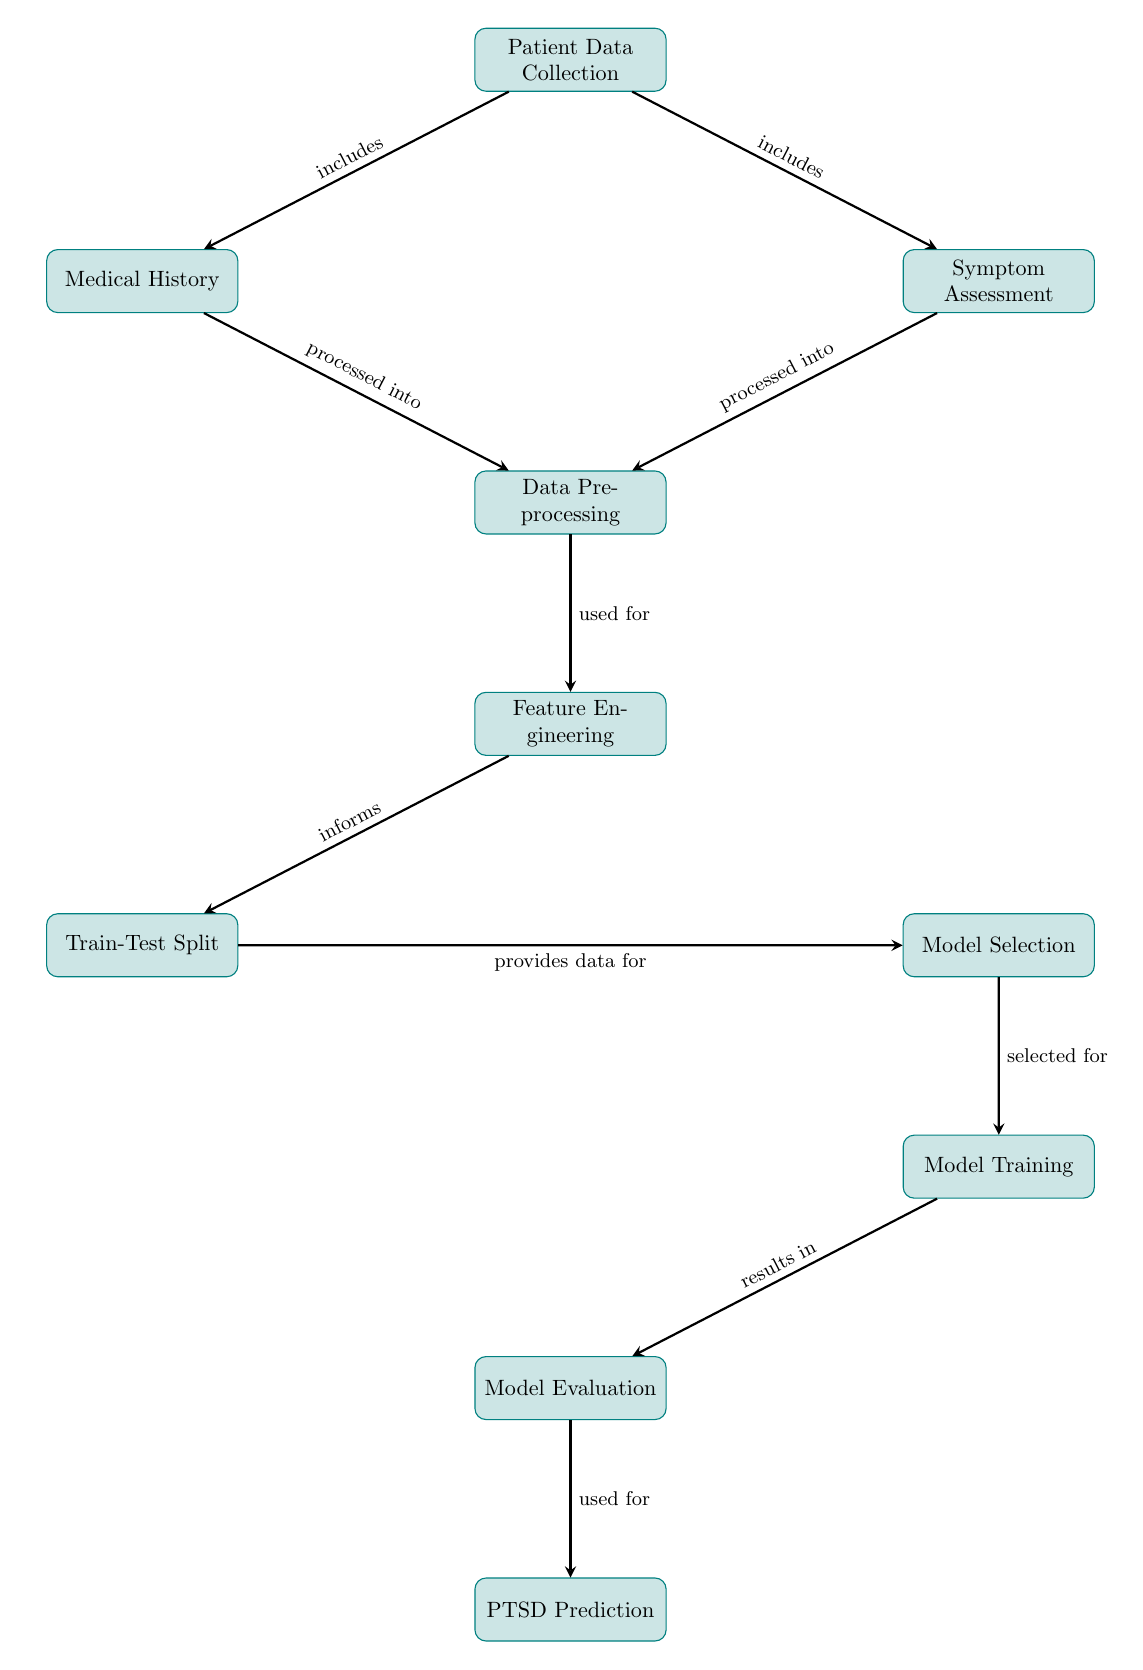What is the first step in the process? The diagram shows the first node titled "Patient Data Collection," indicating that this is the initial step in the process for PTSD diagnosis prediction.
Answer: Patient Data Collection How many main processes are displayed in the diagram? By counting each node in the diagram, we find that there are ten distinct main processes involved in the PTSD diagnosis prediction workflow.
Answer: Ten What does "Medical History" and "Symptom Assessment" lead to? Both "Medical History" and "Symptom Assessment" are connected through arrows to the node "Data Preprocessing," indicating they both lead to this stage in the process.
Answer: Data Preprocessing Which node comes before "Model Training"? The diagram shows that "Model Selection" is the preceding step that leads to "Model Training," as indicated by the arrow connecting these two nodes.
Answer: Model Selection What is the final outcome of this diagram? According to the diagram, "PTSD Prediction" is at the last node, indicating that this is the final outcome of the entire process described.
Answer: PTSD Prediction Which process informs the training/testing split? The "Feature Engineering" node is described with an arrow pointing to "Train-Test Split," indicating that it informs this particular step in the workflow.
Answer: Feature Engineering Which two nodes are processed into "Data Preprocessing"? The diagram shows that both "Medical History" and "Symptom Assessment" are processed into the node "Data Preprocessing," indicating their direct contribution to this stage.
Answer: Medical History and Symptom Assessment What is the role of "Model Evaluation"? The node "Model Evaluation" is described as being used for "PTSD Prediction," meaning its role is to assess the model's effectiveness before making predictions.
Answer: Used for PTSD Prediction 